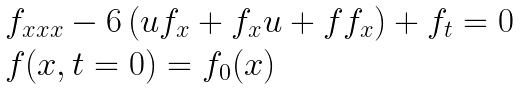<formula> <loc_0><loc_0><loc_500><loc_500>\begin{array} { l } f _ { x x x } - 6 \left ( u f _ { x } + f _ { x } u + f f _ { x } \right ) + f _ { t } = 0 \\ f ( x , t = 0 ) = f _ { 0 } ( x ) \end{array}</formula> 